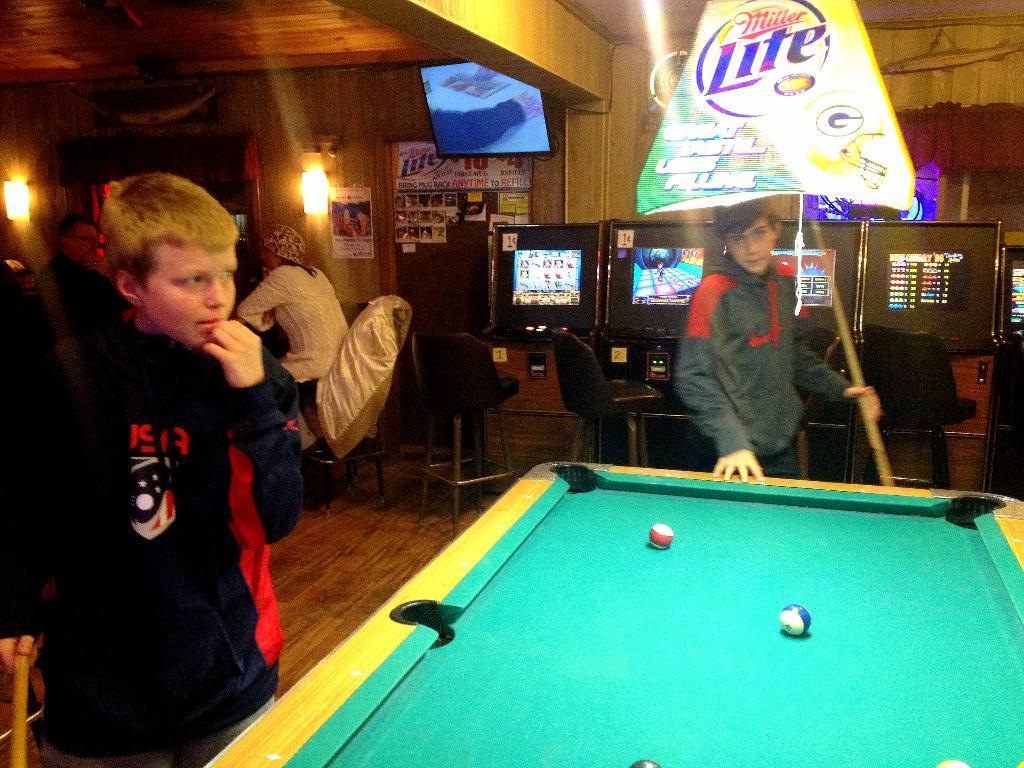Can you describe this image briefly? This picture is taken in the gaming zone. In the center boy is standing holding a stick in his hand. At the left side the boy is standing and holding a stick in his hand. In the background there are two person sitting. There are four monitors, on the top there is one screen, one banner with the name Miller light. On the left side there are two lights hanging on the wall. In the center there is a snooker table with balls on it. 